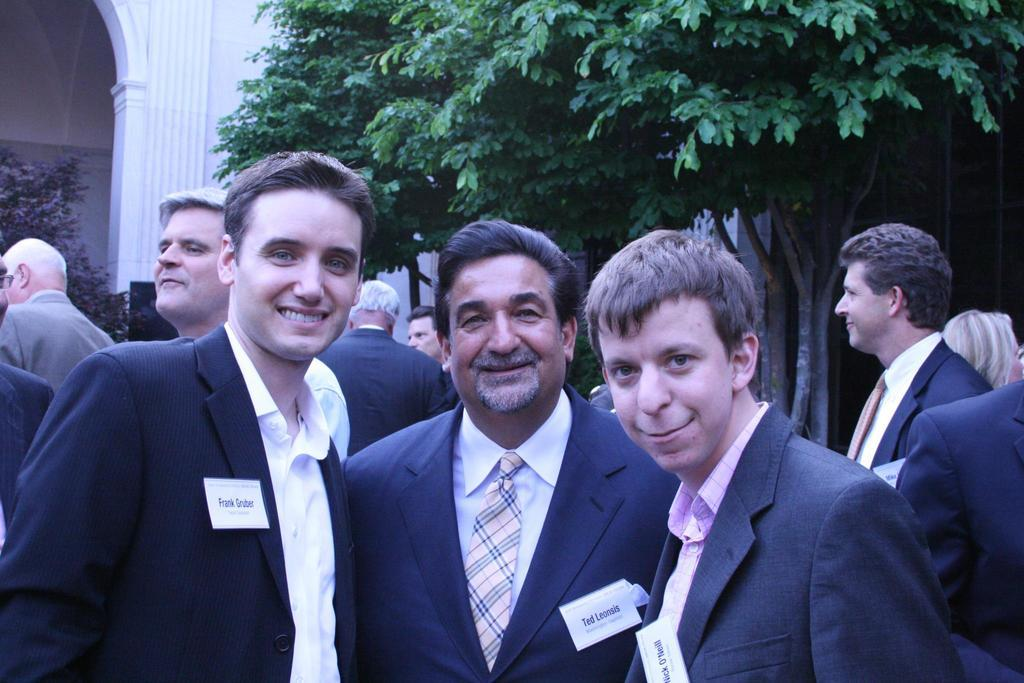How many people are in the image? There is a man and two boys in the image, making a total of three people. What are the people in the image wearing? They are all wearing black suits. What are the people in the image doing? They are standing in the front, smiling, and giving a pose to the camera. What can be seen in the background of the image? There is a tree and a white wall in the background of the image. What type of car can be seen in the background of the image? There is no car visible in the background of the image; it only shows a tree and a white wall. Are the boys taking a recess from their studies in the image? There is no indication in the image that the boys are taking a recess from their studies, as they are dressed in formal attire and posing for a photograph. 